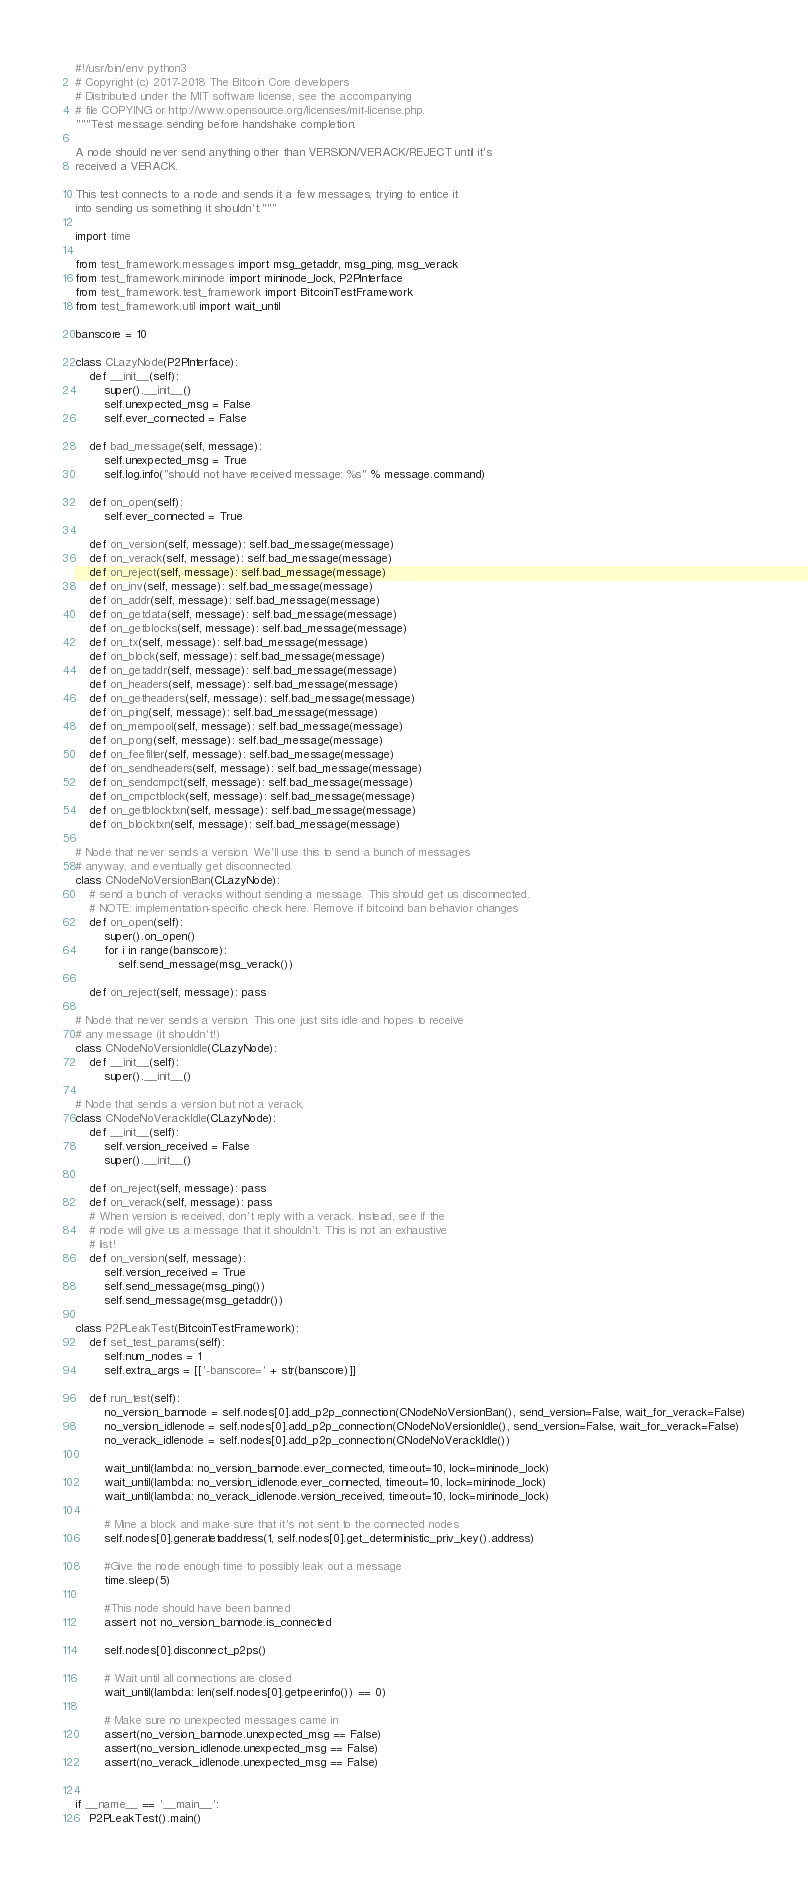<code> <loc_0><loc_0><loc_500><loc_500><_Python_>#!/usr/bin/env python3
# Copyright (c) 2017-2018 The Bitcoin Core developers
# Distributed under the MIT software license, see the accompanying
# file COPYING or http://www.opensource.org/licenses/mit-license.php.
"""Test message sending before handshake completion.

A node should never send anything other than VERSION/VERACK/REJECT until it's
received a VERACK.

This test connects to a node and sends it a few messages, trying to entice it
into sending us something it shouldn't."""

import time

from test_framework.messages import msg_getaddr, msg_ping, msg_verack
from test_framework.mininode import mininode_lock, P2PInterface
from test_framework.test_framework import BitcoinTestFramework
from test_framework.util import wait_until

banscore = 10

class CLazyNode(P2PInterface):
    def __init__(self):
        super().__init__()
        self.unexpected_msg = False
        self.ever_connected = False

    def bad_message(self, message):
        self.unexpected_msg = True
        self.log.info("should not have received message: %s" % message.command)

    def on_open(self):
        self.ever_connected = True

    def on_version(self, message): self.bad_message(message)
    def on_verack(self, message): self.bad_message(message)
    def on_reject(self, message): self.bad_message(message)
    def on_inv(self, message): self.bad_message(message)
    def on_addr(self, message): self.bad_message(message)
    def on_getdata(self, message): self.bad_message(message)
    def on_getblocks(self, message): self.bad_message(message)
    def on_tx(self, message): self.bad_message(message)
    def on_block(self, message): self.bad_message(message)
    def on_getaddr(self, message): self.bad_message(message)
    def on_headers(self, message): self.bad_message(message)
    def on_getheaders(self, message): self.bad_message(message)
    def on_ping(self, message): self.bad_message(message)
    def on_mempool(self, message): self.bad_message(message)
    def on_pong(self, message): self.bad_message(message)
    def on_feefilter(self, message): self.bad_message(message)
    def on_sendheaders(self, message): self.bad_message(message)
    def on_sendcmpct(self, message): self.bad_message(message)
    def on_cmpctblock(self, message): self.bad_message(message)
    def on_getblocktxn(self, message): self.bad_message(message)
    def on_blocktxn(self, message): self.bad_message(message)

# Node that never sends a version. We'll use this to send a bunch of messages
# anyway, and eventually get disconnected.
class CNodeNoVersionBan(CLazyNode):
    # send a bunch of veracks without sending a message. This should get us disconnected.
    # NOTE: implementation-specific check here. Remove if bitcoind ban behavior changes
    def on_open(self):
        super().on_open()
        for i in range(banscore):
            self.send_message(msg_verack())

    def on_reject(self, message): pass

# Node that never sends a version. This one just sits idle and hopes to receive
# any message (it shouldn't!)
class CNodeNoVersionIdle(CLazyNode):
    def __init__(self):
        super().__init__()

# Node that sends a version but not a verack.
class CNodeNoVerackIdle(CLazyNode):
    def __init__(self):
        self.version_received = False
        super().__init__()

    def on_reject(self, message): pass
    def on_verack(self, message): pass
    # When version is received, don't reply with a verack. Instead, see if the
    # node will give us a message that it shouldn't. This is not an exhaustive
    # list!
    def on_version(self, message):
        self.version_received = True
        self.send_message(msg_ping())
        self.send_message(msg_getaddr())

class P2PLeakTest(BitcoinTestFramework):
    def set_test_params(self):
        self.num_nodes = 1
        self.extra_args = [['-banscore=' + str(banscore)]]

    def run_test(self):
        no_version_bannode = self.nodes[0].add_p2p_connection(CNodeNoVersionBan(), send_version=False, wait_for_verack=False)
        no_version_idlenode = self.nodes[0].add_p2p_connection(CNodeNoVersionIdle(), send_version=False, wait_for_verack=False)
        no_verack_idlenode = self.nodes[0].add_p2p_connection(CNodeNoVerackIdle())

        wait_until(lambda: no_version_bannode.ever_connected, timeout=10, lock=mininode_lock)
        wait_until(lambda: no_version_idlenode.ever_connected, timeout=10, lock=mininode_lock)
        wait_until(lambda: no_verack_idlenode.version_received, timeout=10, lock=mininode_lock)

        # Mine a block and make sure that it's not sent to the connected nodes
        self.nodes[0].generatetoaddress(1, self.nodes[0].get_deterministic_priv_key().address)

        #Give the node enough time to possibly leak out a message
        time.sleep(5)

        #This node should have been banned
        assert not no_version_bannode.is_connected

        self.nodes[0].disconnect_p2ps()

        # Wait until all connections are closed
        wait_until(lambda: len(self.nodes[0].getpeerinfo()) == 0)

        # Make sure no unexpected messages came in
        assert(no_version_bannode.unexpected_msg == False)
        assert(no_version_idlenode.unexpected_msg == False)
        assert(no_verack_idlenode.unexpected_msg == False)


if __name__ == '__main__':
    P2PLeakTest().main()
</code> 